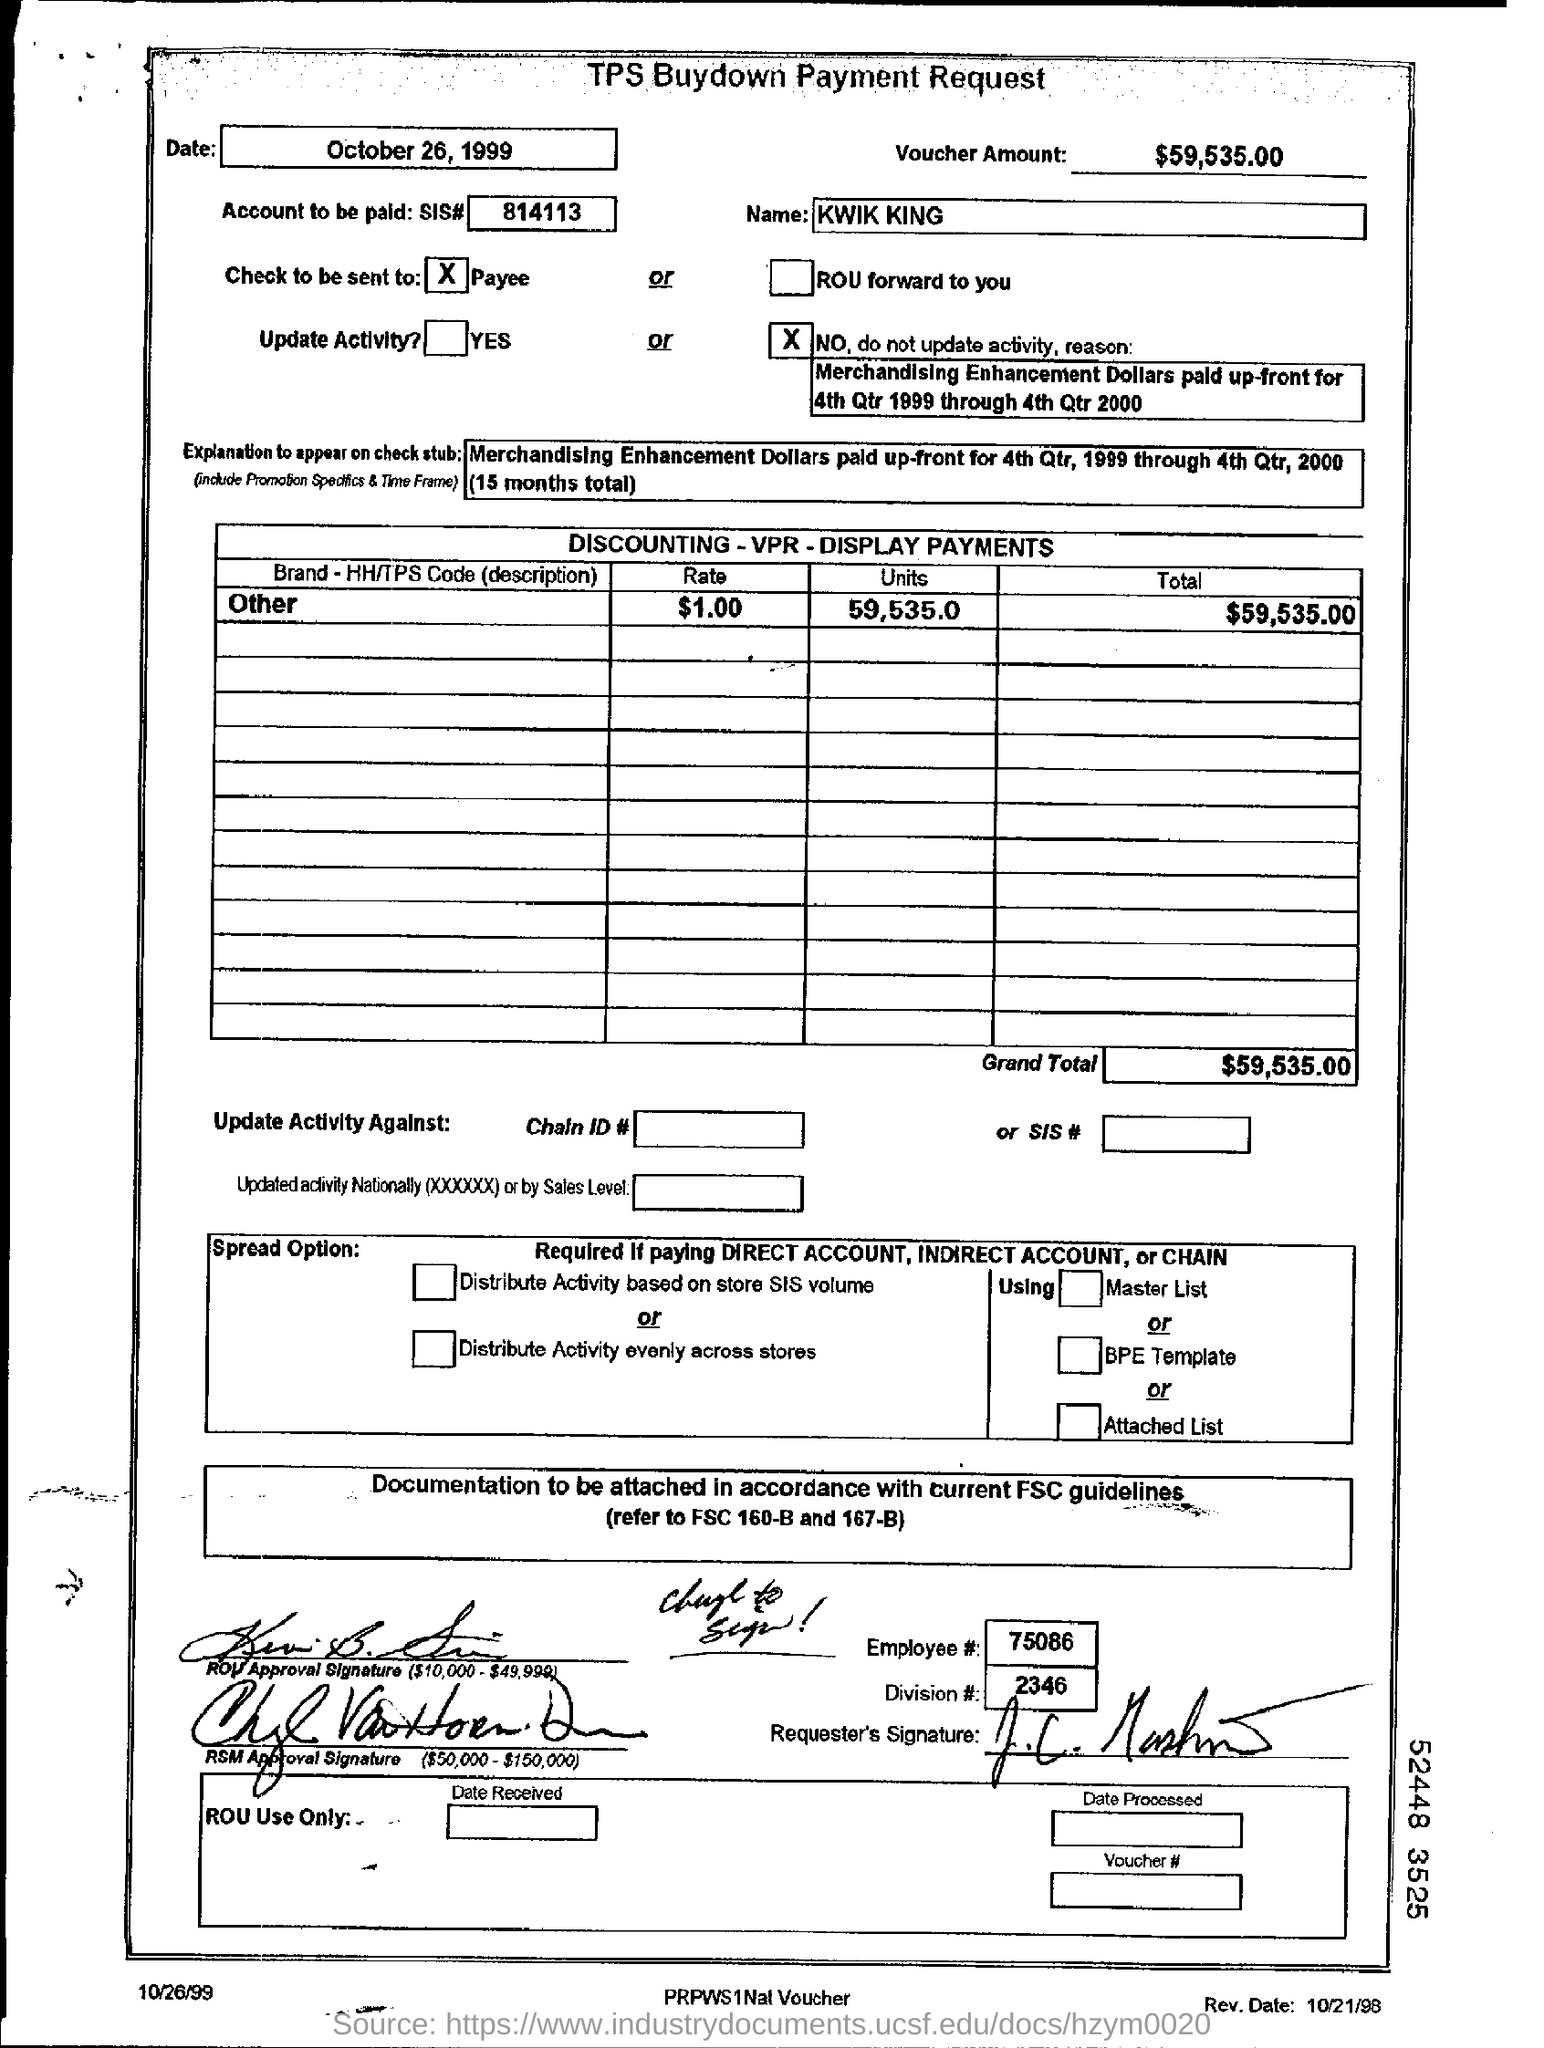How much of amount in the voucher?
Your response must be concise. $59,535.00. What is the name in the tps buydown payment request?
Your response must be concise. KWIK KING. How many units for the brand - hh/tps code (description) for others?
Provide a short and direct response. 59,535.0. How much grand total for the brand - hh/tps code (description) for others?
Offer a terse response. $59,535.00. How much rate for the brand - hh/tps code (description) for others?
Keep it short and to the point. $1.00. 